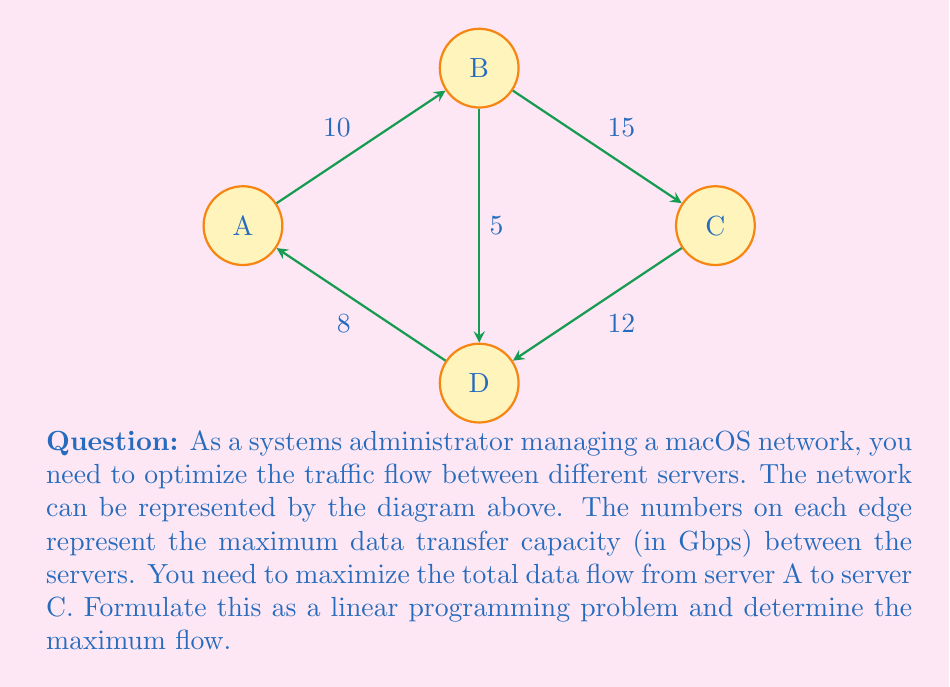Teach me how to tackle this problem. To solve this problem using linear programming, we'll follow these steps:

1) Define variables:
   Let $x_{ij}$ represent the flow from node i to node j.

2) Objective function:
   Maximize the flow from A to C:
   $$\text{Maximize } Z = x_{AB} + x_{AD}$$

3) Constraints:
   a) Flow conservation at each node:
      Node B: $x_{AB} = x_{BC} + x_{BD}$
      Node D: $x_{AD} + x_{BD} = x_{DC}$

   b) Capacity constraints:
      $x_{AB} \leq 10$
      $x_{AD} \leq 8$
      $x_{BC} \leq 15$
      $x_{BD} \leq 5$
      $x_{DC} \leq 12$

   c) Non-negativity:
      $x_{AB}, x_{AD}, x_{BC}, x_{BD}, x_{DC} \geq 0$

4) Solve the linear programming problem:
   We can solve this using the simplex method or software tools. The optimal solution is:
   $x_{AB} = 10$, $x_{AD} = 8$, $x_{BC} = 10$, $x_{BD} = 0$, $x_{DC} = 8$

5) Calculate the maximum flow:
   Maximum flow = $x_{AB} + x_{AD} = 10 + 8 = 18$ Gbps

Therefore, the maximum data flow from server A to server C is 18 Gbps.
Answer: 18 Gbps 